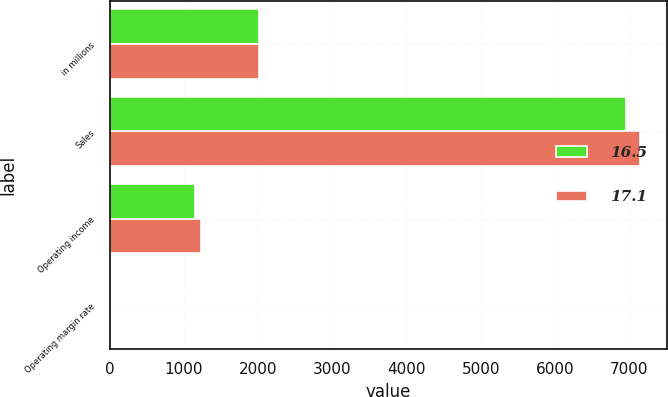<chart> <loc_0><loc_0><loc_500><loc_500><stacked_bar_chart><ecel><fcel>in millions<fcel>Sales<fcel>Operating income<fcel>Operating margin rate<nl><fcel>16.5<fcel>2014<fcel>6951<fcel>1148<fcel>16.5<nl><fcel>17.1<fcel>2013<fcel>7149<fcel>1226<fcel>17.1<nl></chart> 